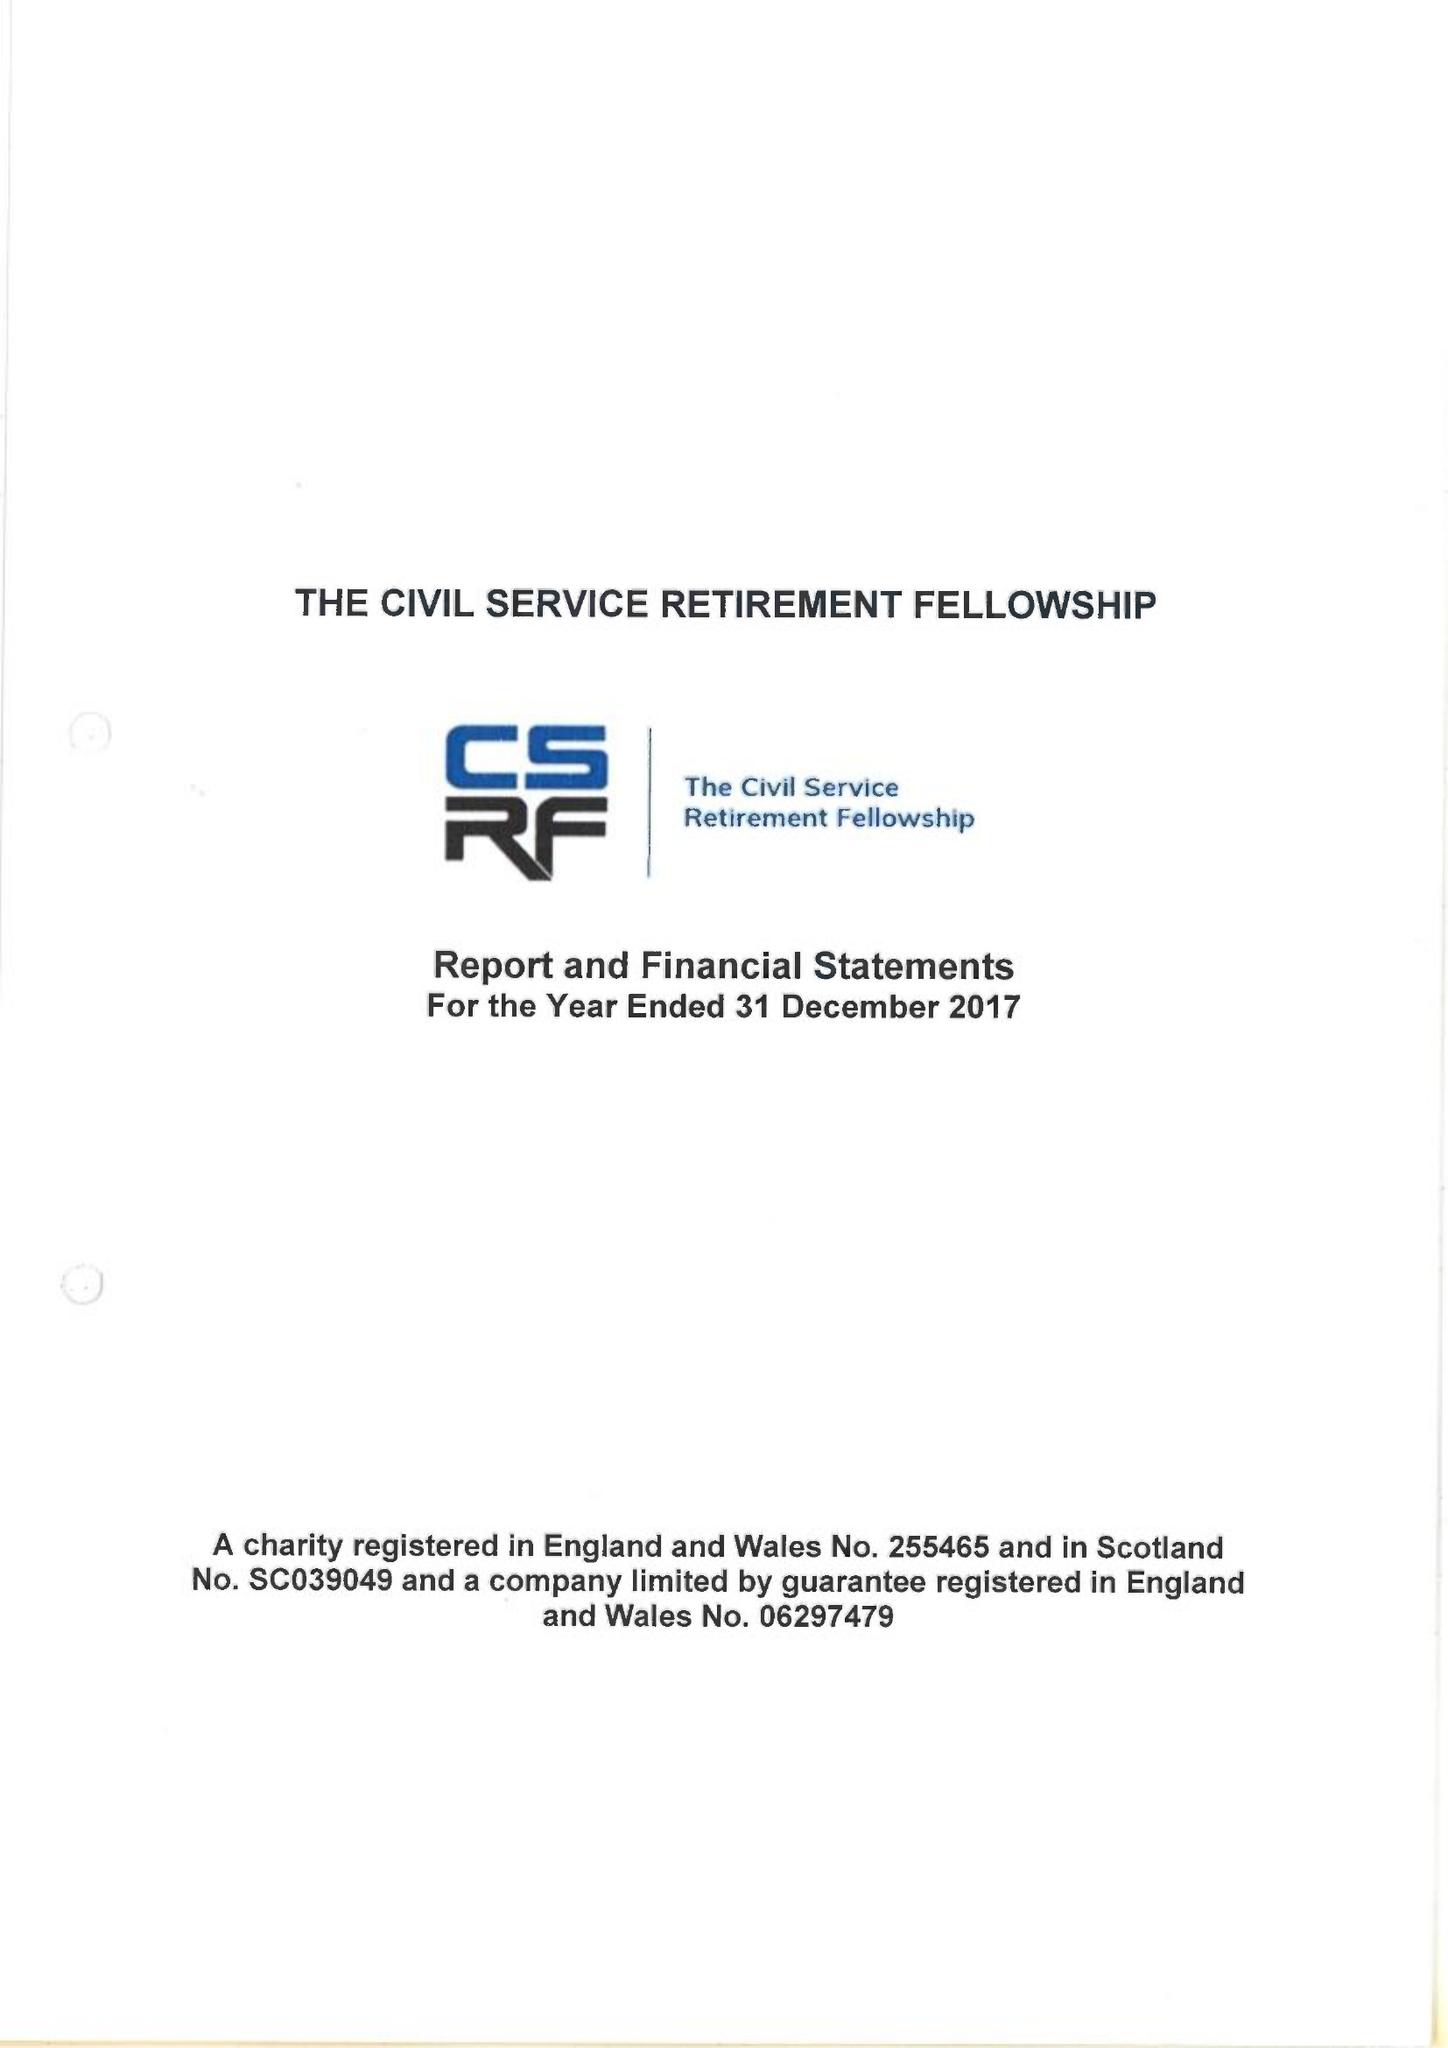What is the value for the charity_name?
Answer the question using a single word or phrase. The Civil Service Retirement Fellowship 